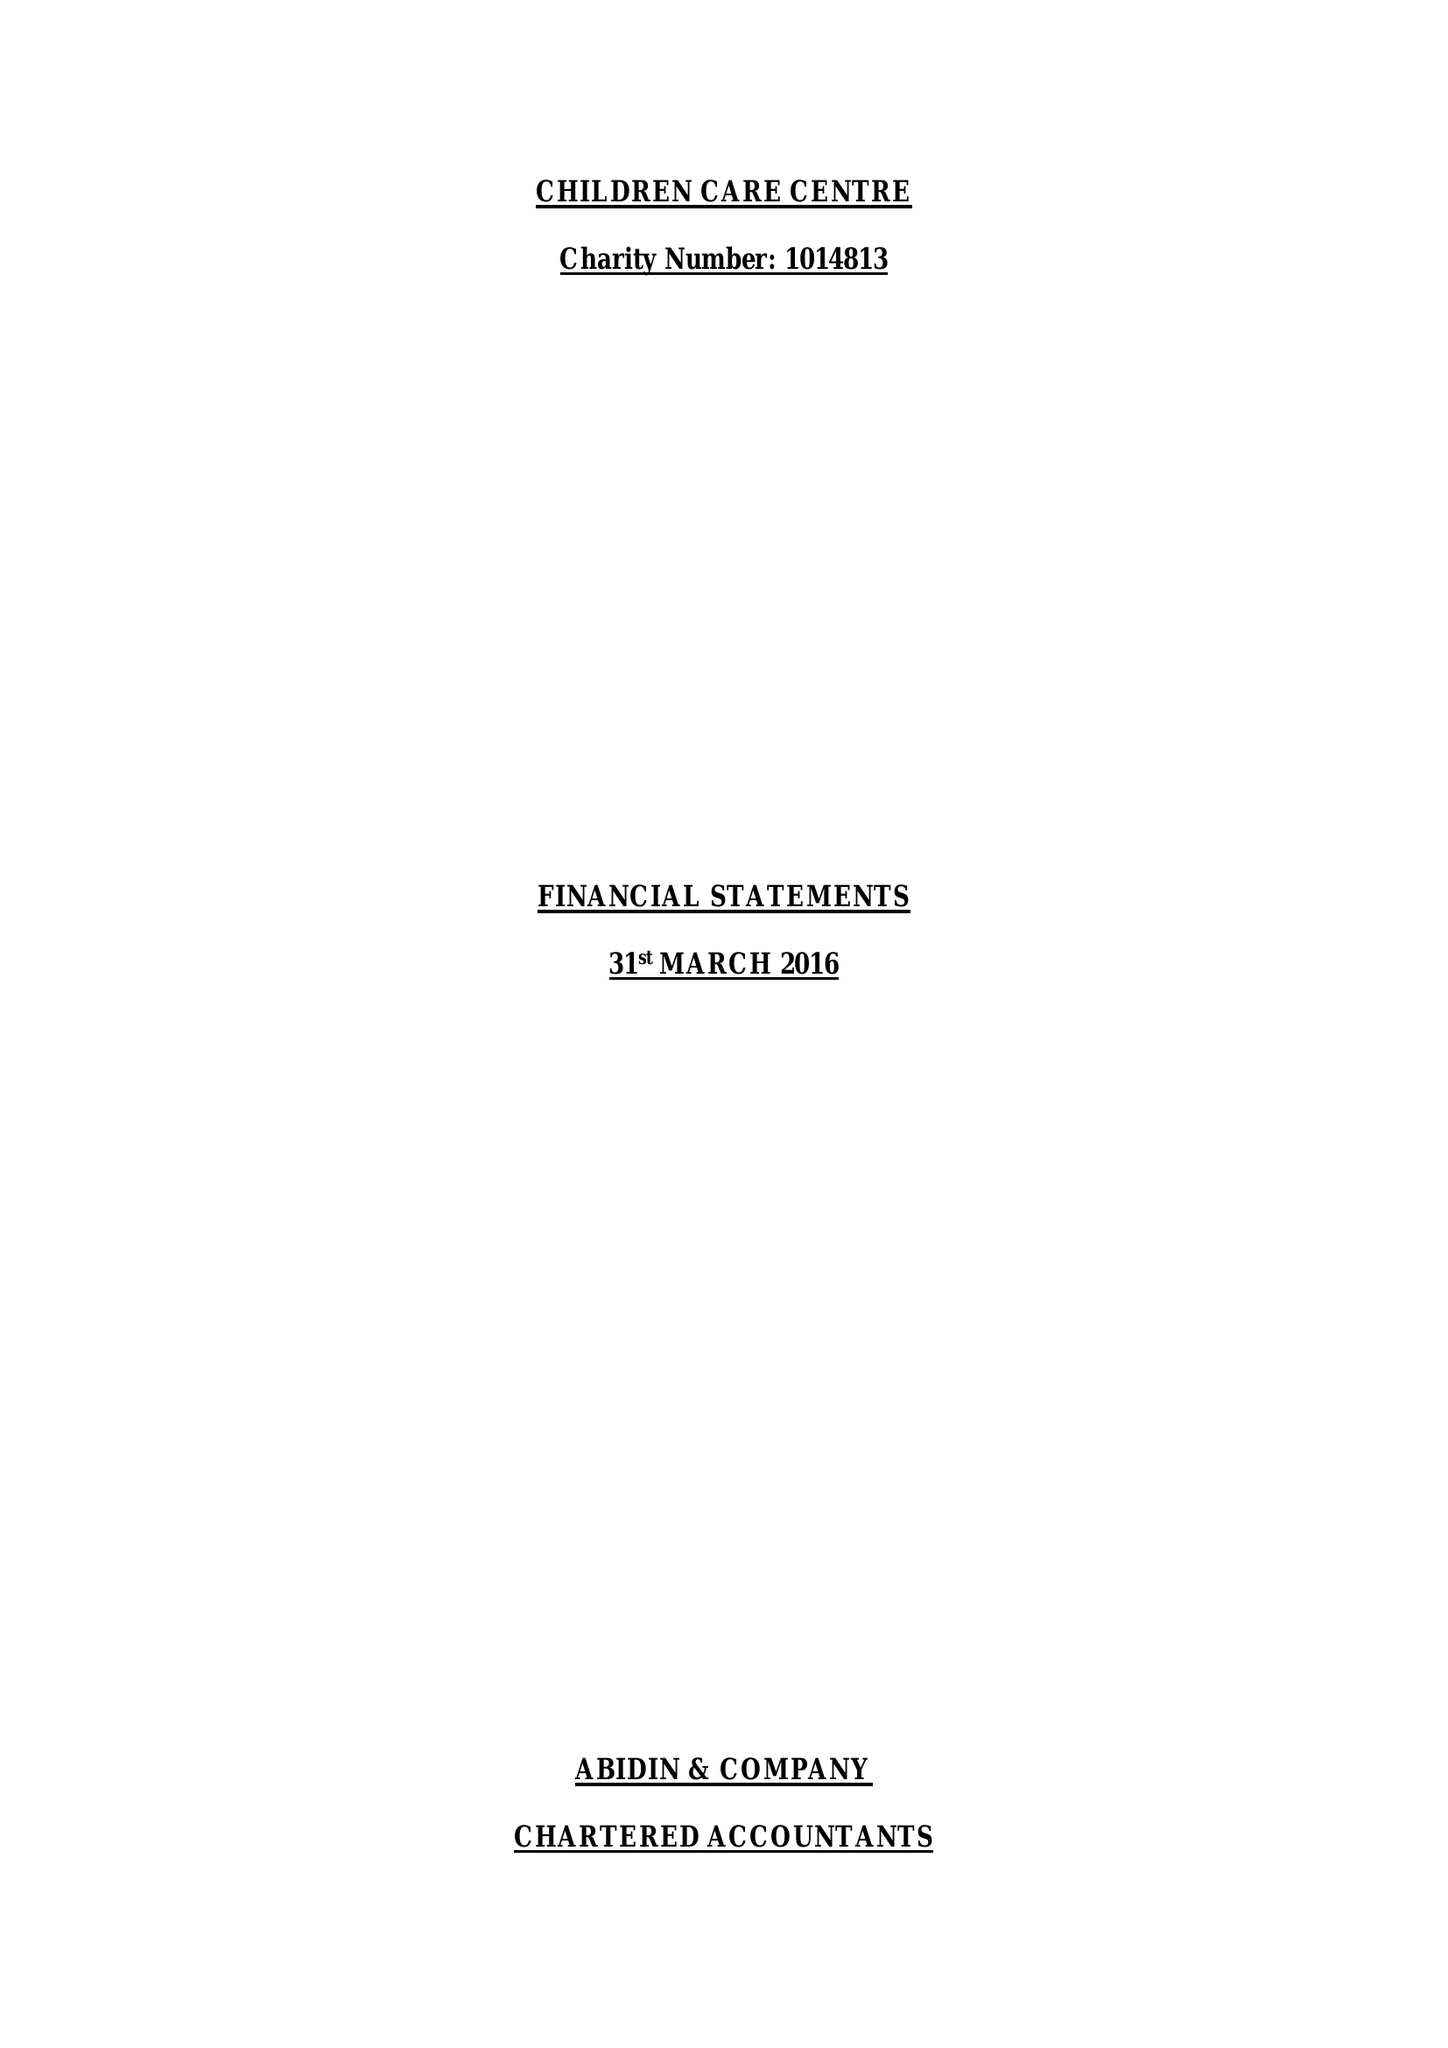What is the value for the income_annually_in_british_pounds?
Answer the question using a single word or phrase. 289193.00 